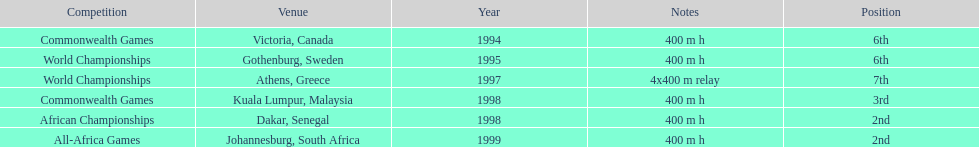What is the quantity of titles ken harden has won? 6. 